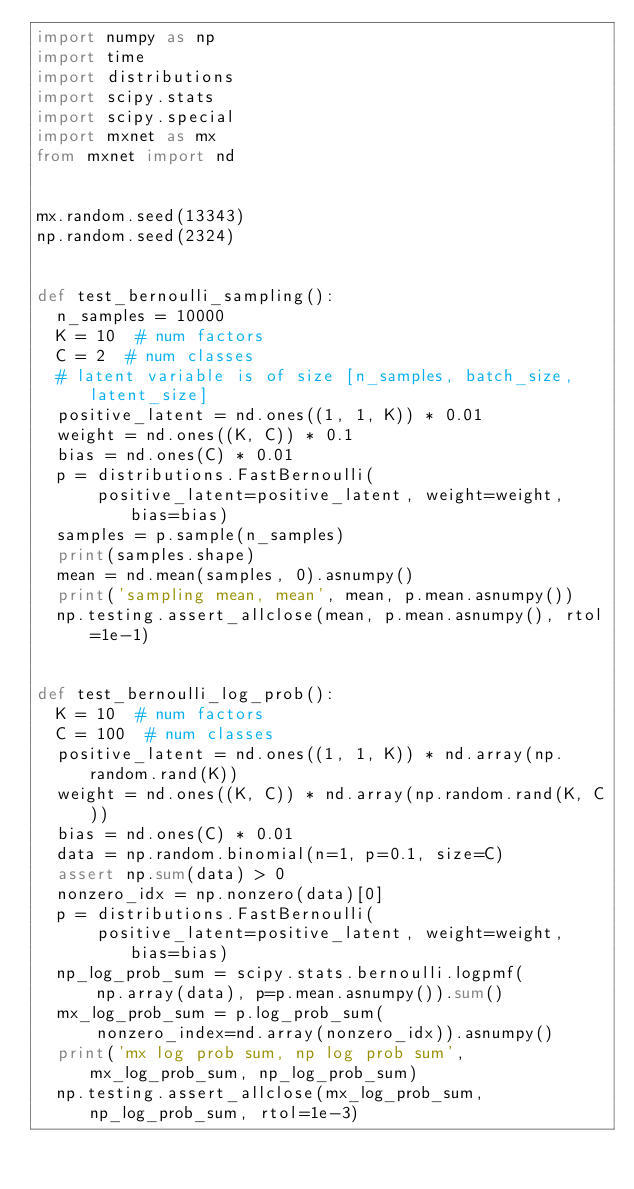<code> <loc_0><loc_0><loc_500><loc_500><_Python_>import numpy as np
import time
import distributions
import scipy.stats
import scipy.special
import mxnet as mx
from mxnet import nd


mx.random.seed(13343)
np.random.seed(2324)


def test_bernoulli_sampling():
  n_samples = 10000
  K = 10  # num factors
  C = 2  # num classes
  # latent variable is of size [n_samples, batch_size, latent_size]
  positive_latent = nd.ones((1, 1, K)) * 0.01
  weight = nd.ones((K, C)) * 0.1
  bias = nd.ones(C) * 0.01
  p = distributions.FastBernoulli(
      positive_latent=positive_latent, weight=weight, bias=bias)
  samples = p.sample(n_samples)
  print(samples.shape)
  mean = nd.mean(samples, 0).asnumpy()
  print('sampling mean, mean', mean, p.mean.asnumpy())
  np.testing.assert_allclose(mean, p.mean.asnumpy(), rtol=1e-1)


def test_bernoulli_log_prob():
  K = 10  # num factors
  C = 100  # num classes
  positive_latent = nd.ones((1, 1, K)) * nd.array(np.random.rand(K))
  weight = nd.ones((K, C)) * nd.array(np.random.rand(K, C))
  bias = nd.ones(C) * 0.01
  data = np.random.binomial(n=1, p=0.1, size=C)
  assert np.sum(data) > 0
  nonzero_idx = np.nonzero(data)[0]
  p = distributions.FastBernoulli(
      positive_latent=positive_latent, weight=weight, bias=bias)
  np_log_prob_sum = scipy.stats.bernoulli.logpmf(
      np.array(data), p=p.mean.asnumpy()).sum()
  mx_log_prob_sum = p.log_prob_sum(
      nonzero_index=nd.array(nonzero_idx)).asnumpy()
  print('mx log prob sum, np log prob sum', mx_log_prob_sum, np_log_prob_sum)
  np.testing.assert_allclose(mx_log_prob_sum, np_log_prob_sum, rtol=1e-3)
</code> 